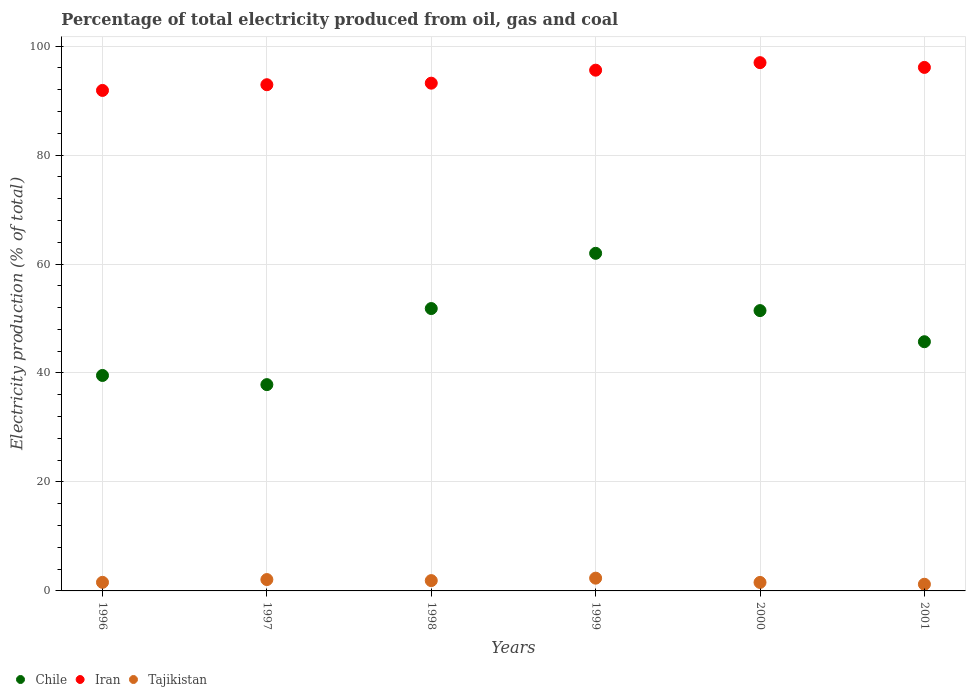How many different coloured dotlines are there?
Your answer should be very brief. 3. Is the number of dotlines equal to the number of legend labels?
Your answer should be very brief. Yes. What is the electricity production in in Tajikistan in 1996?
Keep it short and to the point. 1.57. Across all years, what is the maximum electricity production in in Tajikistan?
Keep it short and to the point. 2.34. Across all years, what is the minimum electricity production in in Chile?
Ensure brevity in your answer.  37.87. In which year was the electricity production in in Iran minimum?
Your response must be concise. 1996. What is the total electricity production in in Iran in the graph?
Keep it short and to the point. 566.61. What is the difference between the electricity production in in Iran in 1997 and that in 1998?
Offer a very short reply. -0.28. What is the difference between the electricity production in in Chile in 1999 and the electricity production in in Iran in 2001?
Your response must be concise. -34.12. What is the average electricity production in in Tajikistan per year?
Your response must be concise. 1.78. In the year 1996, what is the difference between the electricity production in in Chile and electricity production in in Iran?
Your response must be concise. -52.32. What is the ratio of the electricity production in in Iran in 1996 to that in 2001?
Offer a terse response. 0.96. What is the difference between the highest and the second highest electricity production in in Iran?
Make the answer very short. 0.87. What is the difference between the highest and the lowest electricity production in in Chile?
Provide a succinct answer. 24.1. Is the sum of the electricity production in in Iran in 1999 and 2000 greater than the maximum electricity production in in Chile across all years?
Offer a very short reply. Yes. Does the electricity production in in Chile monotonically increase over the years?
Keep it short and to the point. No. Is the electricity production in in Tajikistan strictly greater than the electricity production in in Iran over the years?
Provide a short and direct response. No. Is the electricity production in in Tajikistan strictly less than the electricity production in in Chile over the years?
Keep it short and to the point. Yes. How many dotlines are there?
Your answer should be compact. 3. How many years are there in the graph?
Offer a very short reply. 6. Are the values on the major ticks of Y-axis written in scientific E-notation?
Keep it short and to the point. No. Where does the legend appear in the graph?
Your answer should be compact. Bottom left. How many legend labels are there?
Your answer should be compact. 3. How are the legend labels stacked?
Your response must be concise. Horizontal. What is the title of the graph?
Keep it short and to the point. Percentage of total electricity produced from oil, gas and coal. What is the label or title of the X-axis?
Offer a very short reply. Years. What is the label or title of the Y-axis?
Offer a very short reply. Electricity production (% of total). What is the Electricity production (% of total) in Chile in 1996?
Make the answer very short. 39.55. What is the Electricity production (% of total) of Iran in 1996?
Your answer should be compact. 91.87. What is the Electricity production (% of total) in Tajikistan in 1996?
Provide a short and direct response. 1.57. What is the Electricity production (% of total) in Chile in 1997?
Ensure brevity in your answer.  37.87. What is the Electricity production (% of total) of Iran in 1997?
Make the answer very short. 92.91. What is the Electricity production (% of total) of Tajikistan in 1997?
Ensure brevity in your answer.  2.08. What is the Electricity production (% of total) in Chile in 1998?
Provide a succinct answer. 51.83. What is the Electricity production (% of total) of Iran in 1998?
Provide a short and direct response. 93.2. What is the Electricity production (% of total) of Tajikistan in 1998?
Give a very brief answer. 1.89. What is the Electricity production (% of total) in Chile in 1999?
Make the answer very short. 61.97. What is the Electricity production (% of total) of Iran in 1999?
Ensure brevity in your answer.  95.58. What is the Electricity production (% of total) in Tajikistan in 1999?
Your answer should be very brief. 2.34. What is the Electricity production (% of total) in Chile in 2000?
Provide a succinct answer. 51.45. What is the Electricity production (% of total) in Iran in 2000?
Your answer should be compact. 96.96. What is the Electricity production (% of total) in Tajikistan in 2000?
Provide a short and direct response. 1.56. What is the Electricity production (% of total) in Chile in 2001?
Offer a terse response. 45.74. What is the Electricity production (% of total) in Iran in 2001?
Your response must be concise. 96.09. What is the Electricity production (% of total) in Tajikistan in 2001?
Your answer should be very brief. 1.22. Across all years, what is the maximum Electricity production (% of total) of Chile?
Your response must be concise. 61.97. Across all years, what is the maximum Electricity production (% of total) of Iran?
Your answer should be compact. 96.96. Across all years, what is the maximum Electricity production (% of total) of Tajikistan?
Your answer should be very brief. 2.34. Across all years, what is the minimum Electricity production (% of total) in Chile?
Provide a short and direct response. 37.87. Across all years, what is the minimum Electricity production (% of total) in Iran?
Your answer should be compact. 91.87. Across all years, what is the minimum Electricity production (% of total) in Tajikistan?
Ensure brevity in your answer.  1.22. What is the total Electricity production (% of total) in Chile in the graph?
Offer a terse response. 288.4. What is the total Electricity production (% of total) of Iran in the graph?
Keep it short and to the point. 566.61. What is the total Electricity production (% of total) of Tajikistan in the graph?
Your response must be concise. 10.68. What is the difference between the Electricity production (% of total) of Chile in 1996 and that in 1997?
Make the answer very short. 1.68. What is the difference between the Electricity production (% of total) in Iran in 1996 and that in 1997?
Make the answer very short. -1.05. What is the difference between the Electricity production (% of total) of Tajikistan in 1996 and that in 1997?
Your answer should be very brief. -0.51. What is the difference between the Electricity production (% of total) of Chile in 1996 and that in 1998?
Give a very brief answer. -12.28. What is the difference between the Electricity production (% of total) of Iran in 1996 and that in 1998?
Your response must be concise. -1.33. What is the difference between the Electricity production (% of total) in Tajikistan in 1996 and that in 1998?
Keep it short and to the point. -0.32. What is the difference between the Electricity production (% of total) of Chile in 1996 and that in 1999?
Your answer should be compact. -22.42. What is the difference between the Electricity production (% of total) of Iran in 1996 and that in 1999?
Your response must be concise. -3.72. What is the difference between the Electricity production (% of total) of Tajikistan in 1996 and that in 1999?
Your answer should be very brief. -0.77. What is the difference between the Electricity production (% of total) in Chile in 1996 and that in 2000?
Give a very brief answer. -11.91. What is the difference between the Electricity production (% of total) of Iran in 1996 and that in 2000?
Ensure brevity in your answer.  -5.1. What is the difference between the Electricity production (% of total) of Tajikistan in 1996 and that in 2000?
Your response must be concise. 0.02. What is the difference between the Electricity production (% of total) in Chile in 1996 and that in 2001?
Offer a terse response. -6.19. What is the difference between the Electricity production (% of total) in Iran in 1996 and that in 2001?
Keep it short and to the point. -4.22. What is the difference between the Electricity production (% of total) in Tajikistan in 1996 and that in 2001?
Ensure brevity in your answer.  0.35. What is the difference between the Electricity production (% of total) in Chile in 1997 and that in 1998?
Provide a short and direct response. -13.96. What is the difference between the Electricity production (% of total) of Iran in 1997 and that in 1998?
Provide a succinct answer. -0.28. What is the difference between the Electricity production (% of total) of Tajikistan in 1997 and that in 1998?
Your answer should be very brief. 0.19. What is the difference between the Electricity production (% of total) of Chile in 1997 and that in 1999?
Provide a succinct answer. -24.1. What is the difference between the Electricity production (% of total) in Iran in 1997 and that in 1999?
Give a very brief answer. -2.67. What is the difference between the Electricity production (% of total) in Tajikistan in 1997 and that in 1999?
Ensure brevity in your answer.  -0.26. What is the difference between the Electricity production (% of total) of Chile in 1997 and that in 2000?
Give a very brief answer. -13.59. What is the difference between the Electricity production (% of total) in Iran in 1997 and that in 2000?
Make the answer very short. -4.05. What is the difference between the Electricity production (% of total) in Tajikistan in 1997 and that in 2000?
Offer a terse response. 0.53. What is the difference between the Electricity production (% of total) in Chile in 1997 and that in 2001?
Ensure brevity in your answer.  -7.87. What is the difference between the Electricity production (% of total) in Iran in 1997 and that in 2001?
Provide a short and direct response. -3.18. What is the difference between the Electricity production (% of total) in Tajikistan in 1997 and that in 2001?
Make the answer very short. 0.86. What is the difference between the Electricity production (% of total) of Chile in 1998 and that in 1999?
Make the answer very short. -10.14. What is the difference between the Electricity production (% of total) of Iran in 1998 and that in 1999?
Provide a succinct answer. -2.38. What is the difference between the Electricity production (% of total) in Tajikistan in 1998 and that in 1999?
Provide a succinct answer. -0.45. What is the difference between the Electricity production (% of total) in Chile in 1998 and that in 2000?
Give a very brief answer. 0.38. What is the difference between the Electricity production (% of total) of Iran in 1998 and that in 2000?
Offer a very short reply. -3.77. What is the difference between the Electricity production (% of total) in Tajikistan in 1998 and that in 2000?
Give a very brief answer. 0.33. What is the difference between the Electricity production (% of total) in Chile in 1998 and that in 2001?
Ensure brevity in your answer.  6.09. What is the difference between the Electricity production (% of total) in Iran in 1998 and that in 2001?
Keep it short and to the point. -2.89. What is the difference between the Electricity production (% of total) of Tajikistan in 1998 and that in 2001?
Ensure brevity in your answer.  0.67. What is the difference between the Electricity production (% of total) in Chile in 1999 and that in 2000?
Your response must be concise. 10.52. What is the difference between the Electricity production (% of total) in Iran in 1999 and that in 2000?
Offer a very short reply. -1.38. What is the difference between the Electricity production (% of total) in Tajikistan in 1999 and that in 2000?
Give a very brief answer. 0.78. What is the difference between the Electricity production (% of total) in Chile in 1999 and that in 2001?
Keep it short and to the point. 16.23. What is the difference between the Electricity production (% of total) in Iran in 1999 and that in 2001?
Your answer should be compact. -0.51. What is the difference between the Electricity production (% of total) of Tajikistan in 1999 and that in 2001?
Keep it short and to the point. 1.12. What is the difference between the Electricity production (% of total) in Chile in 2000 and that in 2001?
Ensure brevity in your answer.  5.71. What is the difference between the Electricity production (% of total) in Iran in 2000 and that in 2001?
Keep it short and to the point. 0.87. What is the difference between the Electricity production (% of total) in Tajikistan in 2000 and that in 2001?
Give a very brief answer. 0.33. What is the difference between the Electricity production (% of total) in Chile in 1996 and the Electricity production (% of total) in Iran in 1997?
Your answer should be compact. -53.37. What is the difference between the Electricity production (% of total) of Chile in 1996 and the Electricity production (% of total) of Tajikistan in 1997?
Your answer should be compact. 37.46. What is the difference between the Electricity production (% of total) in Iran in 1996 and the Electricity production (% of total) in Tajikistan in 1997?
Your response must be concise. 89.78. What is the difference between the Electricity production (% of total) of Chile in 1996 and the Electricity production (% of total) of Iran in 1998?
Offer a terse response. -53.65. What is the difference between the Electricity production (% of total) in Chile in 1996 and the Electricity production (% of total) in Tajikistan in 1998?
Provide a short and direct response. 37.65. What is the difference between the Electricity production (% of total) of Iran in 1996 and the Electricity production (% of total) of Tajikistan in 1998?
Offer a terse response. 89.97. What is the difference between the Electricity production (% of total) in Chile in 1996 and the Electricity production (% of total) in Iran in 1999?
Offer a very short reply. -56.03. What is the difference between the Electricity production (% of total) in Chile in 1996 and the Electricity production (% of total) in Tajikistan in 1999?
Your answer should be compact. 37.2. What is the difference between the Electricity production (% of total) in Iran in 1996 and the Electricity production (% of total) in Tajikistan in 1999?
Your answer should be compact. 89.52. What is the difference between the Electricity production (% of total) in Chile in 1996 and the Electricity production (% of total) in Iran in 2000?
Provide a succinct answer. -57.42. What is the difference between the Electricity production (% of total) in Chile in 1996 and the Electricity production (% of total) in Tajikistan in 2000?
Provide a short and direct response. 37.99. What is the difference between the Electricity production (% of total) of Iran in 1996 and the Electricity production (% of total) of Tajikistan in 2000?
Make the answer very short. 90.31. What is the difference between the Electricity production (% of total) of Chile in 1996 and the Electricity production (% of total) of Iran in 2001?
Ensure brevity in your answer.  -56.54. What is the difference between the Electricity production (% of total) in Chile in 1996 and the Electricity production (% of total) in Tajikistan in 2001?
Offer a very short reply. 38.32. What is the difference between the Electricity production (% of total) of Iran in 1996 and the Electricity production (% of total) of Tajikistan in 2001?
Your response must be concise. 90.64. What is the difference between the Electricity production (% of total) of Chile in 1997 and the Electricity production (% of total) of Iran in 1998?
Your response must be concise. -55.33. What is the difference between the Electricity production (% of total) in Chile in 1997 and the Electricity production (% of total) in Tajikistan in 1998?
Your answer should be very brief. 35.97. What is the difference between the Electricity production (% of total) of Iran in 1997 and the Electricity production (% of total) of Tajikistan in 1998?
Offer a very short reply. 91.02. What is the difference between the Electricity production (% of total) in Chile in 1997 and the Electricity production (% of total) in Iran in 1999?
Keep it short and to the point. -57.72. What is the difference between the Electricity production (% of total) in Chile in 1997 and the Electricity production (% of total) in Tajikistan in 1999?
Your response must be concise. 35.52. What is the difference between the Electricity production (% of total) in Iran in 1997 and the Electricity production (% of total) in Tajikistan in 1999?
Make the answer very short. 90.57. What is the difference between the Electricity production (% of total) in Chile in 1997 and the Electricity production (% of total) in Iran in 2000?
Offer a terse response. -59.1. What is the difference between the Electricity production (% of total) in Chile in 1997 and the Electricity production (% of total) in Tajikistan in 2000?
Your answer should be very brief. 36.31. What is the difference between the Electricity production (% of total) in Iran in 1997 and the Electricity production (% of total) in Tajikistan in 2000?
Offer a terse response. 91.35. What is the difference between the Electricity production (% of total) in Chile in 1997 and the Electricity production (% of total) in Iran in 2001?
Your answer should be very brief. -58.22. What is the difference between the Electricity production (% of total) of Chile in 1997 and the Electricity production (% of total) of Tajikistan in 2001?
Offer a terse response. 36.64. What is the difference between the Electricity production (% of total) of Iran in 1997 and the Electricity production (% of total) of Tajikistan in 2001?
Your response must be concise. 91.69. What is the difference between the Electricity production (% of total) in Chile in 1998 and the Electricity production (% of total) in Iran in 1999?
Make the answer very short. -43.75. What is the difference between the Electricity production (% of total) in Chile in 1998 and the Electricity production (% of total) in Tajikistan in 1999?
Provide a succinct answer. 49.49. What is the difference between the Electricity production (% of total) of Iran in 1998 and the Electricity production (% of total) of Tajikistan in 1999?
Give a very brief answer. 90.85. What is the difference between the Electricity production (% of total) in Chile in 1998 and the Electricity production (% of total) in Iran in 2000?
Ensure brevity in your answer.  -45.13. What is the difference between the Electricity production (% of total) of Chile in 1998 and the Electricity production (% of total) of Tajikistan in 2000?
Offer a very short reply. 50.27. What is the difference between the Electricity production (% of total) of Iran in 1998 and the Electricity production (% of total) of Tajikistan in 2000?
Provide a short and direct response. 91.64. What is the difference between the Electricity production (% of total) in Chile in 1998 and the Electricity production (% of total) in Iran in 2001?
Provide a succinct answer. -44.26. What is the difference between the Electricity production (% of total) in Chile in 1998 and the Electricity production (% of total) in Tajikistan in 2001?
Offer a very short reply. 50.61. What is the difference between the Electricity production (% of total) in Iran in 1998 and the Electricity production (% of total) in Tajikistan in 2001?
Offer a very short reply. 91.97. What is the difference between the Electricity production (% of total) in Chile in 1999 and the Electricity production (% of total) in Iran in 2000?
Give a very brief answer. -34.99. What is the difference between the Electricity production (% of total) in Chile in 1999 and the Electricity production (% of total) in Tajikistan in 2000?
Keep it short and to the point. 60.41. What is the difference between the Electricity production (% of total) of Iran in 1999 and the Electricity production (% of total) of Tajikistan in 2000?
Make the answer very short. 94.02. What is the difference between the Electricity production (% of total) in Chile in 1999 and the Electricity production (% of total) in Iran in 2001?
Ensure brevity in your answer.  -34.12. What is the difference between the Electricity production (% of total) in Chile in 1999 and the Electricity production (% of total) in Tajikistan in 2001?
Keep it short and to the point. 60.75. What is the difference between the Electricity production (% of total) in Iran in 1999 and the Electricity production (% of total) in Tajikistan in 2001?
Provide a succinct answer. 94.36. What is the difference between the Electricity production (% of total) of Chile in 2000 and the Electricity production (% of total) of Iran in 2001?
Keep it short and to the point. -44.64. What is the difference between the Electricity production (% of total) in Chile in 2000 and the Electricity production (% of total) in Tajikistan in 2001?
Your answer should be compact. 50.23. What is the difference between the Electricity production (% of total) in Iran in 2000 and the Electricity production (% of total) in Tajikistan in 2001?
Ensure brevity in your answer.  95.74. What is the average Electricity production (% of total) of Chile per year?
Provide a short and direct response. 48.07. What is the average Electricity production (% of total) in Iran per year?
Make the answer very short. 94.43. What is the average Electricity production (% of total) in Tajikistan per year?
Keep it short and to the point. 1.78. In the year 1996, what is the difference between the Electricity production (% of total) of Chile and Electricity production (% of total) of Iran?
Keep it short and to the point. -52.32. In the year 1996, what is the difference between the Electricity production (% of total) of Chile and Electricity production (% of total) of Tajikistan?
Give a very brief answer. 37.97. In the year 1996, what is the difference between the Electricity production (% of total) of Iran and Electricity production (% of total) of Tajikistan?
Provide a short and direct response. 90.29. In the year 1997, what is the difference between the Electricity production (% of total) of Chile and Electricity production (% of total) of Iran?
Your answer should be very brief. -55.05. In the year 1997, what is the difference between the Electricity production (% of total) of Chile and Electricity production (% of total) of Tajikistan?
Your response must be concise. 35.78. In the year 1997, what is the difference between the Electricity production (% of total) in Iran and Electricity production (% of total) in Tajikistan?
Your answer should be very brief. 90.83. In the year 1998, what is the difference between the Electricity production (% of total) of Chile and Electricity production (% of total) of Iran?
Your answer should be very brief. -41.37. In the year 1998, what is the difference between the Electricity production (% of total) in Chile and Electricity production (% of total) in Tajikistan?
Keep it short and to the point. 49.94. In the year 1998, what is the difference between the Electricity production (% of total) of Iran and Electricity production (% of total) of Tajikistan?
Offer a very short reply. 91.3. In the year 1999, what is the difference between the Electricity production (% of total) of Chile and Electricity production (% of total) of Iran?
Offer a terse response. -33.61. In the year 1999, what is the difference between the Electricity production (% of total) of Chile and Electricity production (% of total) of Tajikistan?
Make the answer very short. 59.63. In the year 1999, what is the difference between the Electricity production (% of total) of Iran and Electricity production (% of total) of Tajikistan?
Offer a terse response. 93.24. In the year 2000, what is the difference between the Electricity production (% of total) in Chile and Electricity production (% of total) in Iran?
Keep it short and to the point. -45.51. In the year 2000, what is the difference between the Electricity production (% of total) of Chile and Electricity production (% of total) of Tajikistan?
Offer a very short reply. 49.89. In the year 2000, what is the difference between the Electricity production (% of total) in Iran and Electricity production (% of total) in Tajikistan?
Ensure brevity in your answer.  95.4. In the year 2001, what is the difference between the Electricity production (% of total) of Chile and Electricity production (% of total) of Iran?
Your answer should be very brief. -50.35. In the year 2001, what is the difference between the Electricity production (% of total) of Chile and Electricity production (% of total) of Tajikistan?
Your response must be concise. 44.51. In the year 2001, what is the difference between the Electricity production (% of total) in Iran and Electricity production (% of total) in Tajikistan?
Provide a short and direct response. 94.87. What is the ratio of the Electricity production (% of total) of Chile in 1996 to that in 1997?
Offer a very short reply. 1.04. What is the ratio of the Electricity production (% of total) of Iran in 1996 to that in 1997?
Ensure brevity in your answer.  0.99. What is the ratio of the Electricity production (% of total) in Tajikistan in 1996 to that in 1997?
Your response must be concise. 0.75. What is the ratio of the Electricity production (% of total) in Chile in 1996 to that in 1998?
Provide a short and direct response. 0.76. What is the ratio of the Electricity production (% of total) of Iran in 1996 to that in 1998?
Your answer should be very brief. 0.99. What is the ratio of the Electricity production (% of total) in Tajikistan in 1996 to that in 1998?
Ensure brevity in your answer.  0.83. What is the ratio of the Electricity production (% of total) in Chile in 1996 to that in 1999?
Offer a very short reply. 0.64. What is the ratio of the Electricity production (% of total) in Iran in 1996 to that in 1999?
Offer a very short reply. 0.96. What is the ratio of the Electricity production (% of total) of Tajikistan in 1996 to that in 1999?
Ensure brevity in your answer.  0.67. What is the ratio of the Electricity production (% of total) in Chile in 1996 to that in 2000?
Provide a succinct answer. 0.77. What is the ratio of the Electricity production (% of total) of Iran in 1996 to that in 2000?
Give a very brief answer. 0.95. What is the ratio of the Electricity production (% of total) in Tajikistan in 1996 to that in 2000?
Your answer should be very brief. 1.01. What is the ratio of the Electricity production (% of total) of Chile in 1996 to that in 2001?
Your response must be concise. 0.86. What is the ratio of the Electricity production (% of total) of Iran in 1996 to that in 2001?
Make the answer very short. 0.96. What is the ratio of the Electricity production (% of total) of Tajikistan in 1996 to that in 2001?
Your response must be concise. 1.29. What is the ratio of the Electricity production (% of total) of Chile in 1997 to that in 1998?
Offer a terse response. 0.73. What is the ratio of the Electricity production (% of total) in Tajikistan in 1997 to that in 1998?
Ensure brevity in your answer.  1.1. What is the ratio of the Electricity production (% of total) in Chile in 1997 to that in 1999?
Give a very brief answer. 0.61. What is the ratio of the Electricity production (% of total) in Iran in 1997 to that in 1999?
Offer a terse response. 0.97. What is the ratio of the Electricity production (% of total) of Tajikistan in 1997 to that in 1999?
Keep it short and to the point. 0.89. What is the ratio of the Electricity production (% of total) in Chile in 1997 to that in 2000?
Your answer should be very brief. 0.74. What is the ratio of the Electricity production (% of total) of Iran in 1997 to that in 2000?
Your answer should be very brief. 0.96. What is the ratio of the Electricity production (% of total) in Tajikistan in 1997 to that in 2000?
Keep it short and to the point. 1.34. What is the ratio of the Electricity production (% of total) of Chile in 1997 to that in 2001?
Your answer should be compact. 0.83. What is the ratio of the Electricity production (% of total) in Iran in 1997 to that in 2001?
Offer a terse response. 0.97. What is the ratio of the Electricity production (% of total) in Tajikistan in 1997 to that in 2001?
Provide a short and direct response. 1.7. What is the ratio of the Electricity production (% of total) of Chile in 1998 to that in 1999?
Offer a terse response. 0.84. What is the ratio of the Electricity production (% of total) of Iran in 1998 to that in 1999?
Make the answer very short. 0.98. What is the ratio of the Electricity production (% of total) of Tajikistan in 1998 to that in 1999?
Your answer should be compact. 0.81. What is the ratio of the Electricity production (% of total) in Chile in 1998 to that in 2000?
Provide a short and direct response. 1.01. What is the ratio of the Electricity production (% of total) of Iran in 1998 to that in 2000?
Offer a very short reply. 0.96. What is the ratio of the Electricity production (% of total) in Tajikistan in 1998 to that in 2000?
Your response must be concise. 1.21. What is the ratio of the Electricity production (% of total) of Chile in 1998 to that in 2001?
Give a very brief answer. 1.13. What is the ratio of the Electricity production (% of total) of Iran in 1998 to that in 2001?
Ensure brevity in your answer.  0.97. What is the ratio of the Electricity production (% of total) of Tajikistan in 1998 to that in 2001?
Your answer should be very brief. 1.55. What is the ratio of the Electricity production (% of total) of Chile in 1999 to that in 2000?
Your answer should be compact. 1.2. What is the ratio of the Electricity production (% of total) in Iran in 1999 to that in 2000?
Your answer should be very brief. 0.99. What is the ratio of the Electricity production (% of total) in Tajikistan in 1999 to that in 2000?
Ensure brevity in your answer.  1.5. What is the ratio of the Electricity production (% of total) in Chile in 1999 to that in 2001?
Offer a terse response. 1.35. What is the ratio of the Electricity production (% of total) of Tajikistan in 1999 to that in 2001?
Ensure brevity in your answer.  1.91. What is the ratio of the Electricity production (% of total) in Chile in 2000 to that in 2001?
Offer a very short reply. 1.12. What is the ratio of the Electricity production (% of total) in Iran in 2000 to that in 2001?
Give a very brief answer. 1.01. What is the ratio of the Electricity production (% of total) of Tajikistan in 2000 to that in 2001?
Your answer should be very brief. 1.27. What is the difference between the highest and the second highest Electricity production (% of total) in Chile?
Ensure brevity in your answer.  10.14. What is the difference between the highest and the second highest Electricity production (% of total) in Iran?
Offer a very short reply. 0.87. What is the difference between the highest and the second highest Electricity production (% of total) in Tajikistan?
Provide a succinct answer. 0.26. What is the difference between the highest and the lowest Electricity production (% of total) of Chile?
Your response must be concise. 24.1. What is the difference between the highest and the lowest Electricity production (% of total) of Iran?
Give a very brief answer. 5.1. What is the difference between the highest and the lowest Electricity production (% of total) in Tajikistan?
Provide a succinct answer. 1.12. 